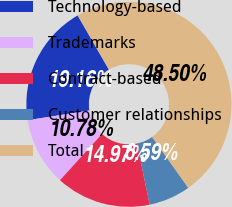<chart> <loc_0><loc_0><loc_500><loc_500><pie_chart><fcel>Technology-based<fcel>Trademarks<fcel>Contract-based<fcel>Customer relationships<fcel>Total<nl><fcel>19.16%<fcel>10.78%<fcel>14.97%<fcel>6.59%<fcel>48.5%<nl></chart> 